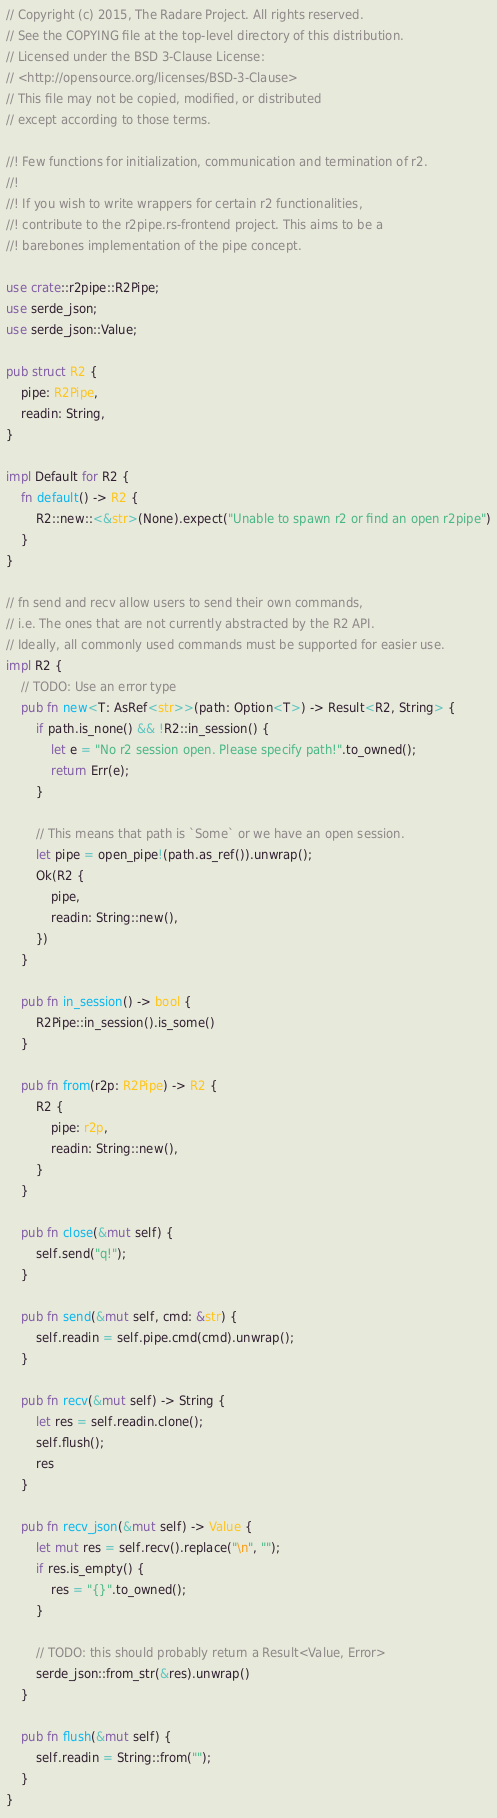Convert code to text. <code><loc_0><loc_0><loc_500><loc_500><_Rust_>// Copyright (c) 2015, The Radare Project. All rights reserved.
// See the COPYING file at the top-level directory of this distribution.
// Licensed under the BSD 3-Clause License:
// <http://opensource.org/licenses/BSD-3-Clause>
// This file may not be copied, modified, or distributed
// except according to those terms.

//! Few functions for initialization, communication and termination of r2.
//!
//! If you wish to write wrappers for certain r2 functionalities,
//! contribute to the r2pipe.rs-frontend project. This aims to be a
//! barebones implementation of the pipe concept.

use crate::r2pipe::R2Pipe;
use serde_json;
use serde_json::Value;

pub struct R2 {
    pipe: R2Pipe,
    readin: String,
}

impl Default for R2 {
    fn default() -> R2 {
        R2::new::<&str>(None).expect("Unable to spawn r2 or find an open r2pipe")
    }
}

// fn send and recv allow users to send their own commands,
// i.e. The ones that are not currently abstracted by the R2 API.
// Ideally, all commonly used commands must be supported for easier use.
impl R2 {
    // TODO: Use an error type
    pub fn new<T: AsRef<str>>(path: Option<T>) -> Result<R2, String> {
        if path.is_none() && !R2::in_session() {
            let e = "No r2 session open. Please specify path!".to_owned();
            return Err(e);
        }

        // This means that path is `Some` or we have an open session.
        let pipe = open_pipe!(path.as_ref()).unwrap();
        Ok(R2 {
            pipe,
            readin: String::new(),
        })
    }

    pub fn in_session() -> bool {
        R2Pipe::in_session().is_some()
    }

    pub fn from(r2p: R2Pipe) -> R2 {
        R2 {
            pipe: r2p,
            readin: String::new(),
        }
    }

    pub fn close(&mut self) {
        self.send("q!");
    }

    pub fn send(&mut self, cmd: &str) {
        self.readin = self.pipe.cmd(cmd).unwrap();
    }

    pub fn recv(&mut self) -> String {
        let res = self.readin.clone();
        self.flush();
        res
    }

    pub fn recv_json(&mut self) -> Value {
        let mut res = self.recv().replace("\n", "");
        if res.is_empty() {
            res = "{}".to_owned();
        }

        // TODO: this should probably return a Result<Value, Error>
        serde_json::from_str(&res).unwrap()
    }

    pub fn flush(&mut self) {
        self.readin = String::from("");
    }
}
</code> 